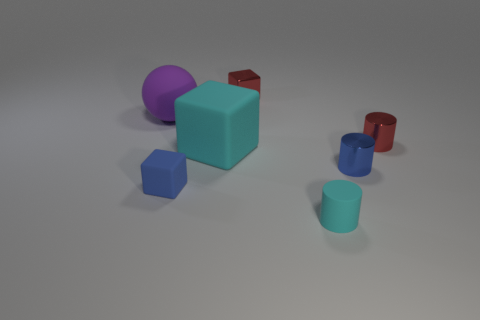Add 2 small yellow matte objects. How many objects exist? 9 Subtract all spheres. How many objects are left? 6 Subtract 1 purple balls. How many objects are left? 6 Subtract all green metal objects. Subtract all small cyan cylinders. How many objects are left? 6 Add 1 small shiny cylinders. How many small shiny cylinders are left? 3 Add 5 big cyan rubber cubes. How many big cyan rubber cubes exist? 6 